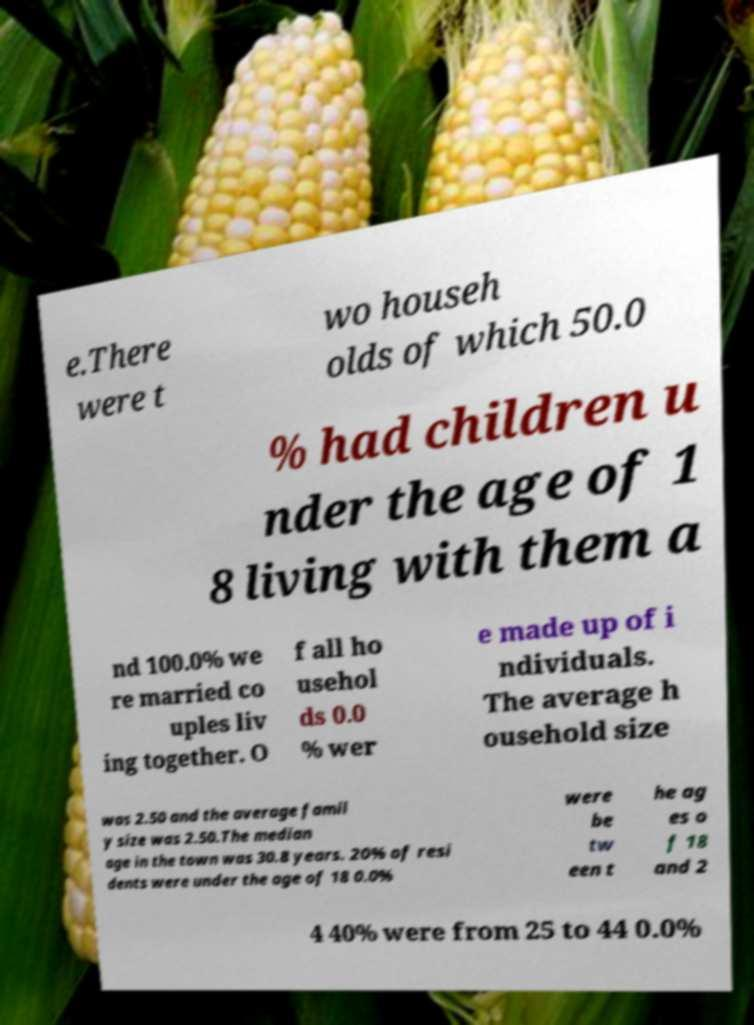What messages or text are displayed in this image? I need them in a readable, typed format. e.There were t wo househ olds of which 50.0 % had children u nder the age of 1 8 living with them a nd 100.0% we re married co uples liv ing together. O f all ho usehol ds 0.0 % wer e made up of i ndividuals. The average h ousehold size was 2.50 and the average famil y size was 2.50.The median age in the town was 30.8 years. 20% of resi dents were under the age of 18 0.0% were be tw een t he ag es o f 18 and 2 4 40% were from 25 to 44 0.0% 